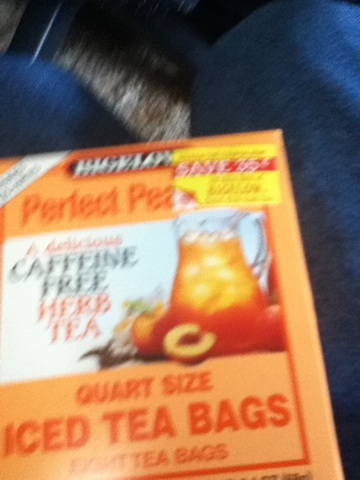What is this? This is a box of Perfect Peach quart-sized iced tea bags. The tea bags are designed to make a delicious caffeine-free peach-flavored iced tea. 